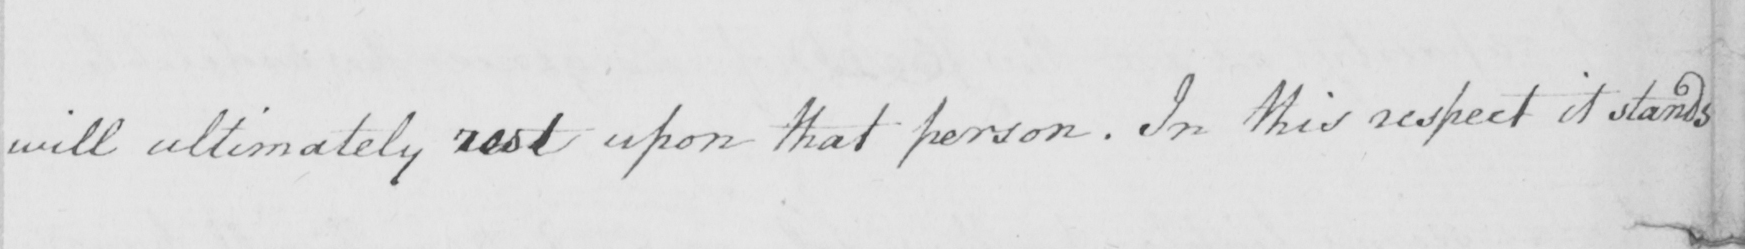Can you tell me what this handwritten text says? will ultimately rest upon that person . In this respect it stands 